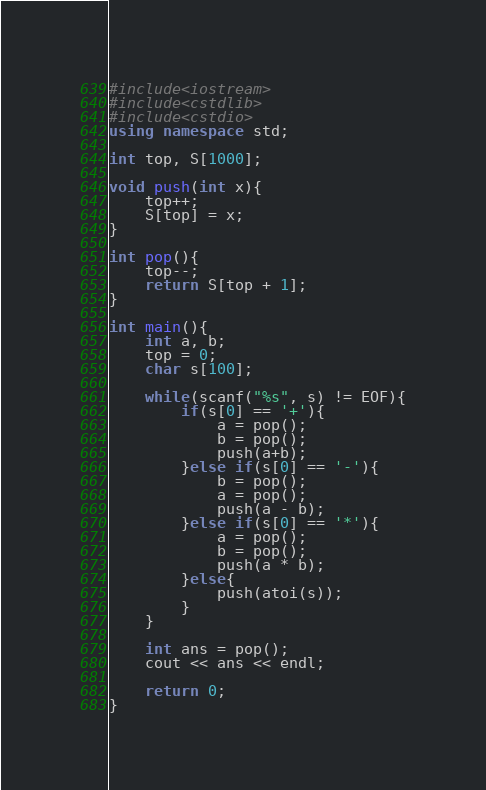Convert code to text. <code><loc_0><loc_0><loc_500><loc_500><_C++_>#include<iostream>
#include<cstdlib>
#include<cstdio>
using namespace std;

int top, S[1000];

void push(int x){
    top++;
    S[top] = x;
}

int pop(){
    top--;
    return S[top + 1];
}

int main(){
    int a, b;
    top = 0;
    char s[100];
    
    while(scanf("%s", s) != EOF){
        if(s[0] == '+'){
            a = pop();
            b = pop();
            push(a+b);
        }else if(s[0] == '-'){
            b = pop();
            a = pop();
            push(a - b);
        }else if(s[0] == '*'){
            a = pop();
            b = pop();
            push(a * b);
        }else{
            push(atoi(s));
        }
    }
    
    int ans = pop();
    cout << ans << endl;
    
    return 0;
}
</code> 